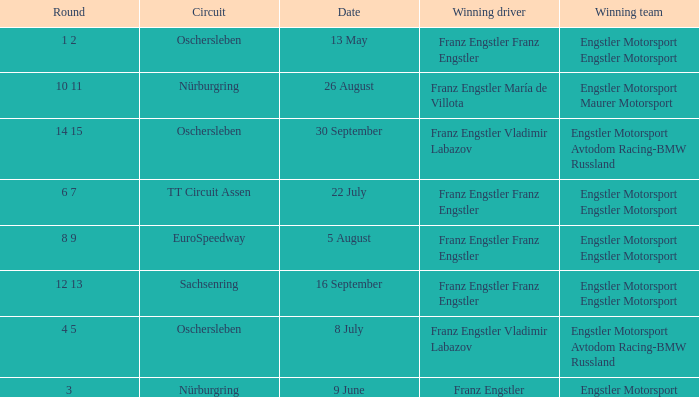What Round was the Winning Team Engstler Motorsport Maurer Motorsport? 10 11. 